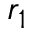Convert formula to latex. <formula><loc_0><loc_0><loc_500><loc_500>r _ { 1 }</formula> 